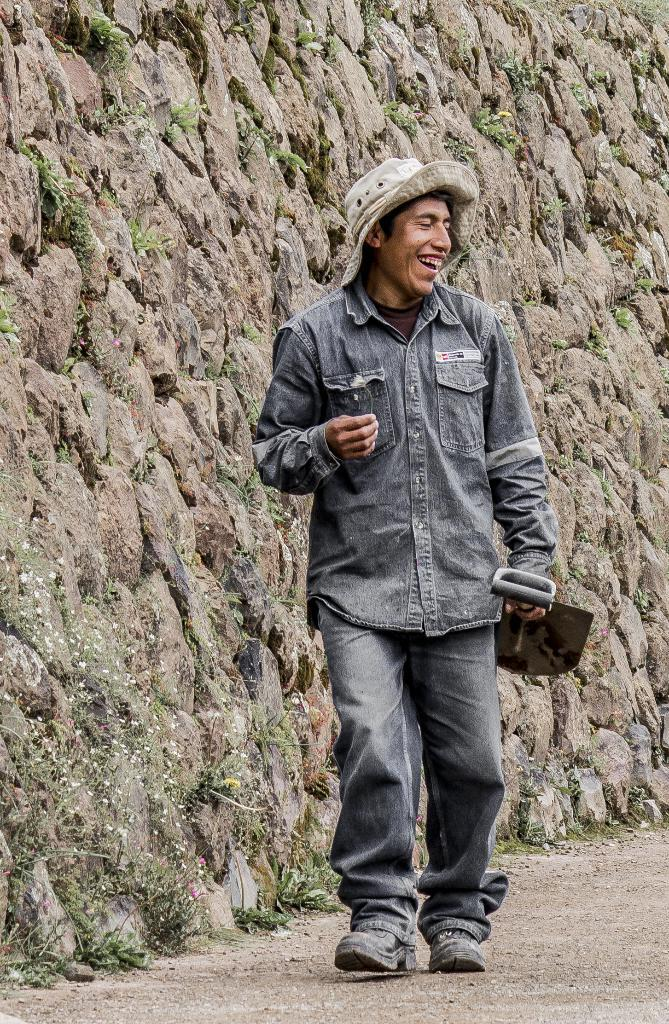What is the main subject of the image? There is a person in the image. What is the person wearing? The person is wearing a hat. What is the person holding? The person is holding a shovel. What is the person doing in the image? The person is walking. What type of background can be seen in the image? There is a rock wall and grass visible in the image. What type of engine can be seen in the image? There is no engine present in the image. How many tomatoes are visible on the rock wall in the image? There are no tomatoes visible in the image; the rock wall is the only feature mentioned in the background. 